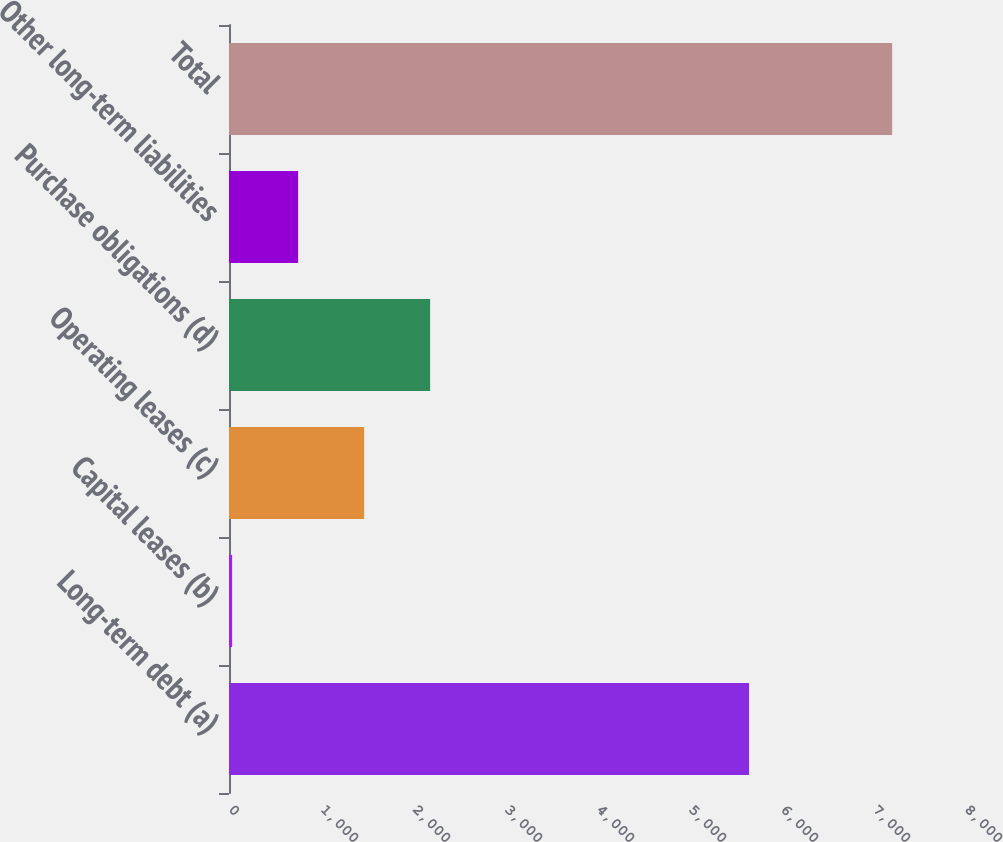<chart> <loc_0><loc_0><loc_500><loc_500><bar_chart><fcel>Long-term debt (a)<fcel>Capital leases (b)<fcel>Operating leases (c)<fcel>Purchase obligations (d)<fcel>Other long-term liabilities<fcel>Total<nl><fcel>5653<fcel>34<fcel>1468.8<fcel>2186.2<fcel>751.4<fcel>7208<nl></chart> 